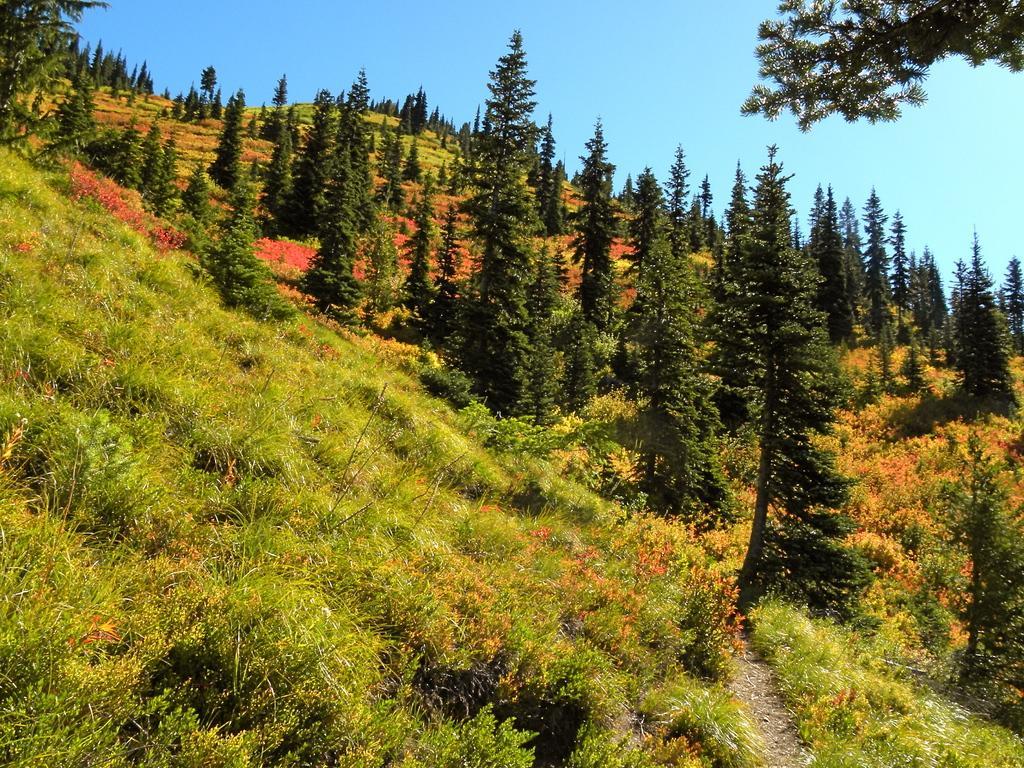How would you summarize this image in a sentence or two? In this image we can see there is a grass, trees and a sky. 